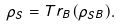<formula> <loc_0><loc_0><loc_500><loc_500>\rho _ { S } = T r _ { B } ( \rho _ { S B } ) .</formula> 